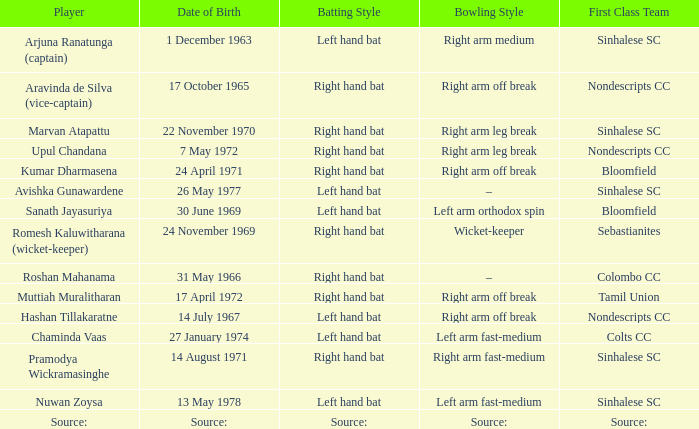Who has a bowling style of source:? Source:. 